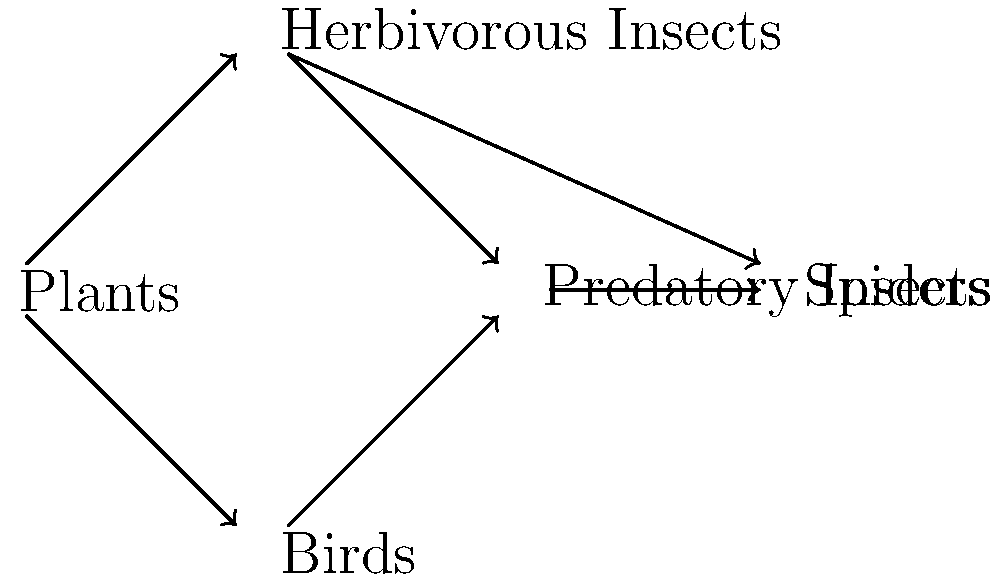In the given food web network, which organism group serves as both a predator and prey for insects? To answer this question, we need to analyze the relationships between different organisms in the food web:

1. Plants are at the base of the food web, serving as primary producers.
2. Herbivorous insects feed on plants, as shown by the arrow from plants to herbivorous insects.
3. Predatory insects feed on herbivorous insects, indicated by the arrow from herbivorous to predatory insects.
4. Birds feed on both herbivorous and predatory insects, as shown by the arrows connecting them.
5. Spiders feed on predatory insects, as indicated by the arrow from predatory insects to spiders.

Looking at the predatory insects, we can see that:
a) They prey on herbivorous insects (arrow pointing from herbivorous to predatory insects)
b) They are preyed upon by both birds and spiders (arrows pointing from predatory insects to birds and spiders)

Therefore, predatory insects serve as both predators (of herbivorous insects) and prey (for birds and spiders) within the insect groups in this food web.
Answer: Predatory insects 